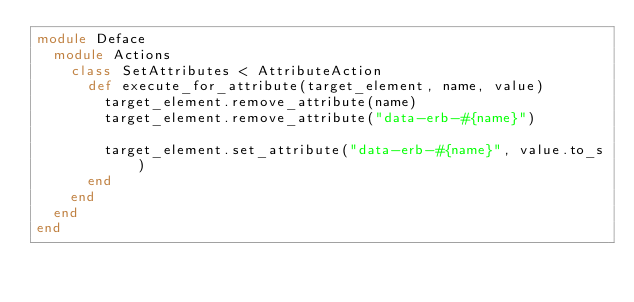<code> <loc_0><loc_0><loc_500><loc_500><_Ruby_>module Deface
  module Actions
    class SetAttributes < AttributeAction
      def execute_for_attribute(target_element, name, value)
        target_element.remove_attribute(name)
        target_element.remove_attribute("data-erb-#{name}")

        target_element.set_attribute("data-erb-#{name}", value.to_s)
      end
    end
  end
end
</code> 